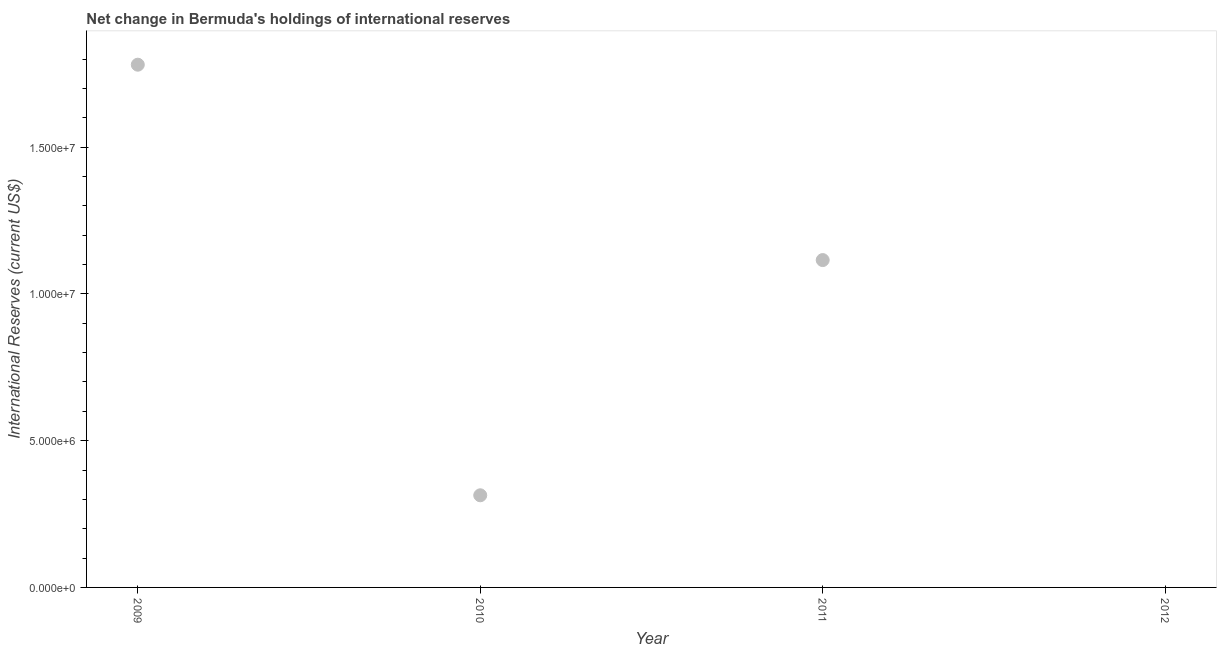What is the reserves and related items in 2009?
Ensure brevity in your answer.  1.78e+07. Across all years, what is the maximum reserves and related items?
Provide a short and direct response. 1.78e+07. What is the sum of the reserves and related items?
Keep it short and to the point. 3.21e+07. What is the difference between the reserves and related items in 2009 and 2010?
Ensure brevity in your answer.  1.47e+07. What is the average reserves and related items per year?
Your answer should be very brief. 8.02e+06. What is the median reserves and related items?
Keep it short and to the point. 7.15e+06. In how many years, is the reserves and related items greater than 17000000 US$?
Offer a very short reply. 1. What is the ratio of the reserves and related items in 2010 to that in 2011?
Your answer should be compact. 0.28. Is the difference between the reserves and related items in 2009 and 2010 greater than the difference between any two years?
Your answer should be very brief. No. What is the difference between the highest and the second highest reserves and related items?
Give a very brief answer. 6.66e+06. Is the sum of the reserves and related items in 2010 and 2011 greater than the maximum reserves and related items across all years?
Offer a terse response. No. What is the difference between the highest and the lowest reserves and related items?
Offer a terse response. 1.78e+07. In how many years, is the reserves and related items greater than the average reserves and related items taken over all years?
Make the answer very short. 2. How many dotlines are there?
Offer a very short reply. 1. How many years are there in the graph?
Give a very brief answer. 4. Does the graph contain any zero values?
Ensure brevity in your answer.  Yes. Does the graph contain grids?
Your answer should be very brief. No. What is the title of the graph?
Give a very brief answer. Net change in Bermuda's holdings of international reserves. What is the label or title of the Y-axis?
Your answer should be compact. International Reserves (current US$). What is the International Reserves (current US$) in 2009?
Provide a short and direct response. 1.78e+07. What is the International Reserves (current US$) in 2010?
Your response must be concise. 3.14e+06. What is the International Reserves (current US$) in 2011?
Make the answer very short. 1.12e+07. What is the difference between the International Reserves (current US$) in 2009 and 2010?
Keep it short and to the point. 1.47e+07. What is the difference between the International Reserves (current US$) in 2009 and 2011?
Your response must be concise. 6.66e+06. What is the difference between the International Reserves (current US$) in 2010 and 2011?
Offer a terse response. -8.01e+06. What is the ratio of the International Reserves (current US$) in 2009 to that in 2010?
Your response must be concise. 5.67. What is the ratio of the International Reserves (current US$) in 2009 to that in 2011?
Ensure brevity in your answer.  1.6. What is the ratio of the International Reserves (current US$) in 2010 to that in 2011?
Your response must be concise. 0.28. 